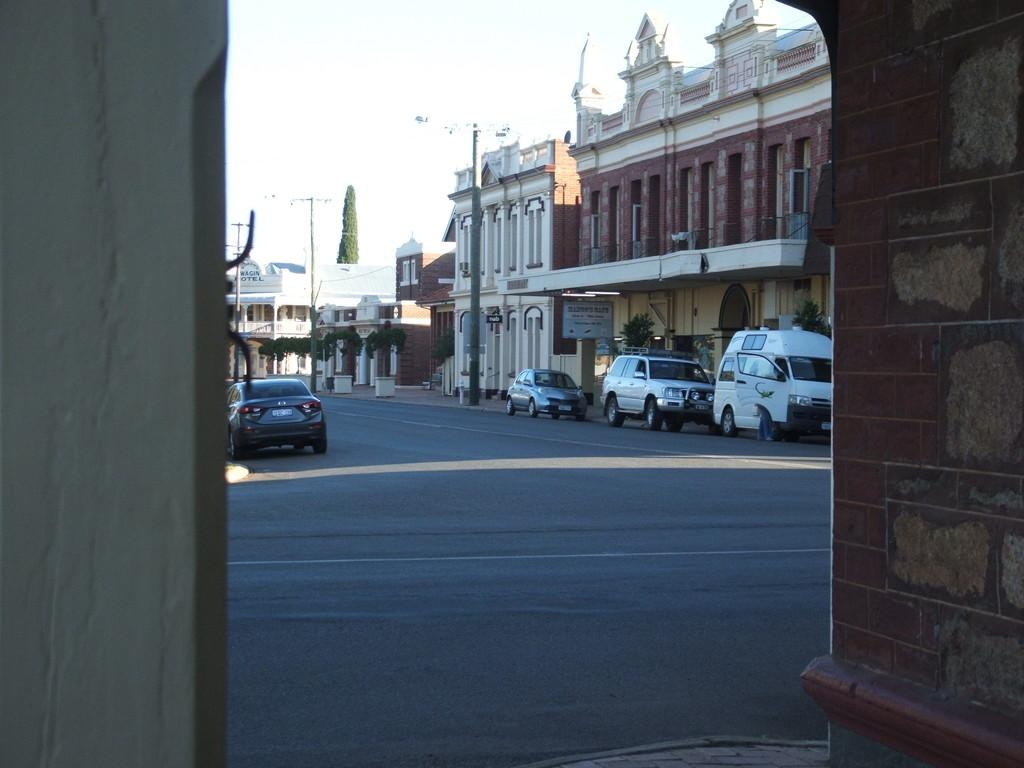What is located at the front of the image? There are walls in the front of the image. What can be seen in the center of the image? There are vehicles on the road in the center of the image. What type of structures are present in the image? There are buildings in the image. What else can be seen in the image besides walls, vehicles, and buildings? There are poles and a tree in the image. What advice does the grandfather give to the driver in the image? There is no grandfather present in the image, so it is not possible to answer that question. 